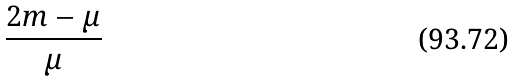<formula> <loc_0><loc_0><loc_500><loc_500>\frac { 2 m - \mu } { \mu }</formula> 